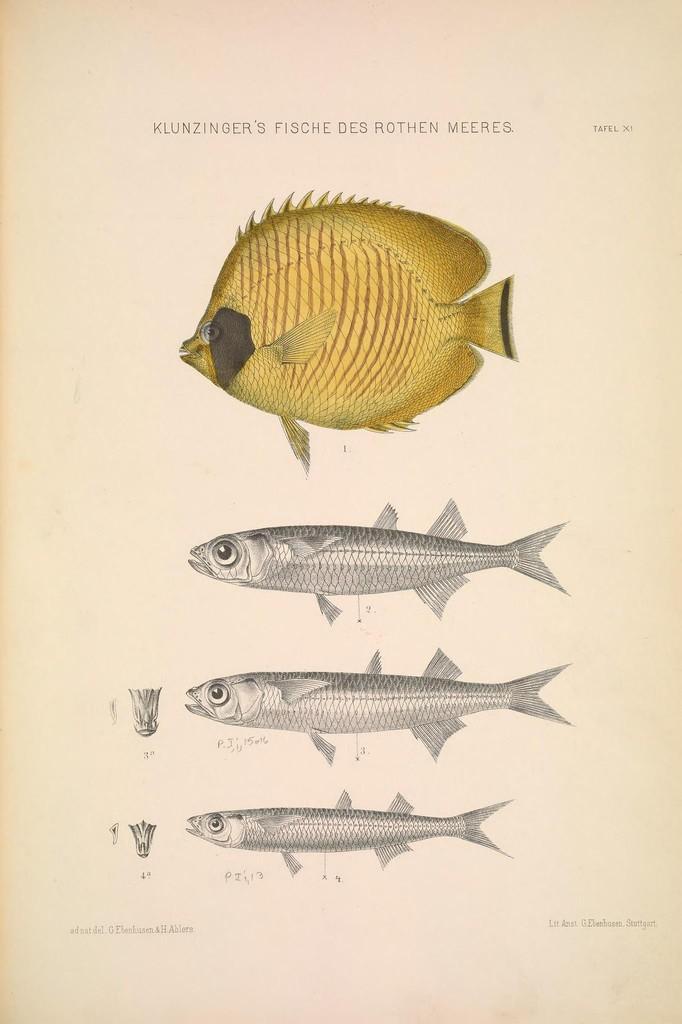Please provide a concise description of this image. In this image we can see pictures of fishes on the paper and there is text. 